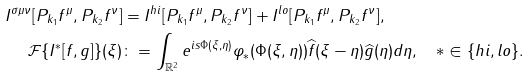Convert formula to latex. <formula><loc_0><loc_0><loc_500><loc_500>I ^ { \sigma \mu \nu } [ P _ { k _ { 1 } } f ^ { \mu } , P _ { k _ { 2 } } f ^ { \nu } ] & = I ^ { h i } [ P _ { k _ { 1 } } f ^ { \mu } , P _ { k _ { 2 } } f ^ { \nu } ] + I ^ { l o } [ P _ { k _ { 1 } } f ^ { \mu } , P _ { k _ { 2 } } f ^ { \nu } ] , \\ \mathcal { F } \{ I ^ { \ast } [ f , g ] \} ( \xi ) & \colon = \int _ { \mathbb { R } ^ { 2 } } e ^ { i s \Phi ( \xi , \eta ) } \varphi _ { \ast } ( \Phi ( \xi , \eta ) ) \widehat { f } ( \xi - \eta ) \widehat { g } ( \eta ) d \eta , \quad \ast \in \{ h i , l o \} .</formula> 